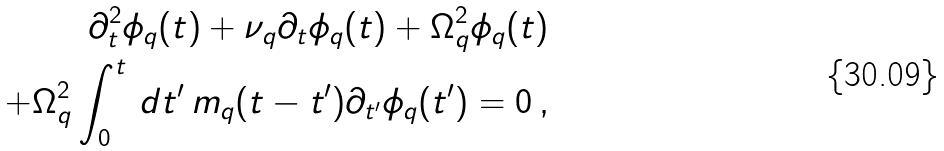Convert formula to latex. <formula><loc_0><loc_0><loc_500><loc_500>\partial _ { t } ^ { 2 } \phi _ { q } ( t ) + \nu _ { q } \partial _ { t } \phi _ { q } ( t ) + \Omega _ { q } ^ { 2 } \phi _ { q } ( t ) \\ + \Omega _ { q } ^ { 2 } \int _ { 0 } ^ { t } \, d t ^ { \prime } \, m _ { q } ( t - t ^ { \prime } ) \partial _ { t ^ { \prime } } \phi _ { q } ( t ^ { \prime } ) = 0 \, ,</formula> 